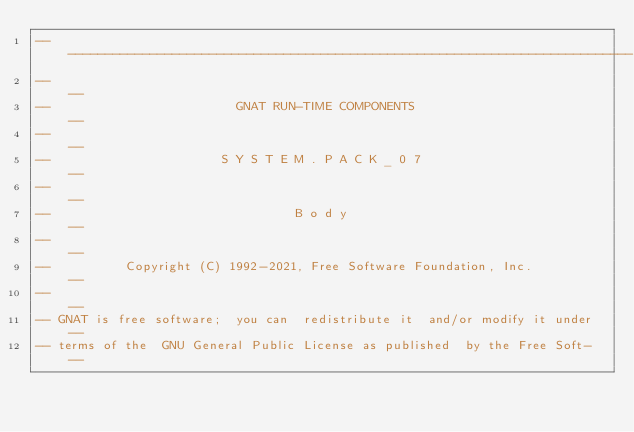Convert code to text. <code><loc_0><loc_0><loc_500><loc_500><_Ada_>------------------------------------------------------------------------------
--                                                                          --
--                         GNAT RUN-TIME COMPONENTS                         --
--                                                                          --
--                       S Y S T E M . P A C K _ 0 7                        --
--                                                                          --
--                                 B o d y                                  --
--                                                                          --
--          Copyright (C) 1992-2021, Free Software Foundation, Inc.         --
--                                                                          --
-- GNAT is free software;  you can  redistribute it  and/or modify it under --
-- terms of the  GNU General Public License as published  by the Free Soft- --</code> 